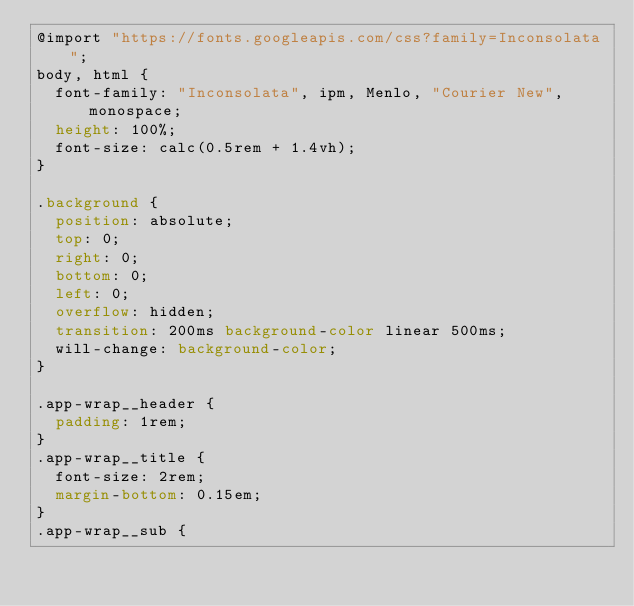<code> <loc_0><loc_0><loc_500><loc_500><_CSS_>@import "https://fonts.googleapis.com/css?family=Inconsolata";
body, html {
  font-family: "Inconsolata", ipm, Menlo, "Courier New", monospace;
  height: 100%;
  font-size: calc(0.5rem + 1.4vh);
}

.background {
  position: absolute;
  top: 0;
  right: 0;
  bottom: 0;
  left: 0;
  overflow: hidden;
  transition: 200ms background-color linear 500ms;
  will-change: background-color;
}

.app-wrap__header {
  padding: 1rem;
}
.app-wrap__title {
  font-size: 2rem;
  margin-bottom: 0.15em;
}
.app-wrap__sub {</code> 